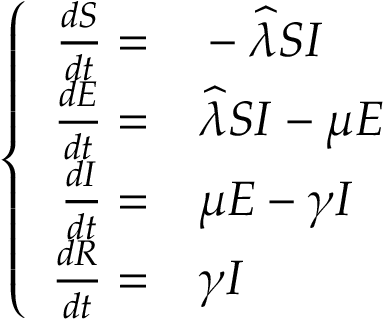<formula> <loc_0><loc_0><loc_500><loc_500>\left \{ \begin{array} { r l } { \frac { d S } { d t } = } & - \widehat { \lambda } S I } \\ { \frac { d E } { d t } = } & \widehat { \lambda } S I - \mu E } \\ { \frac { d I } { d t } = } & \mu E - \gamma I } \\ { \frac { d R } { d t } = } & \gamma I } \end{array}</formula> 